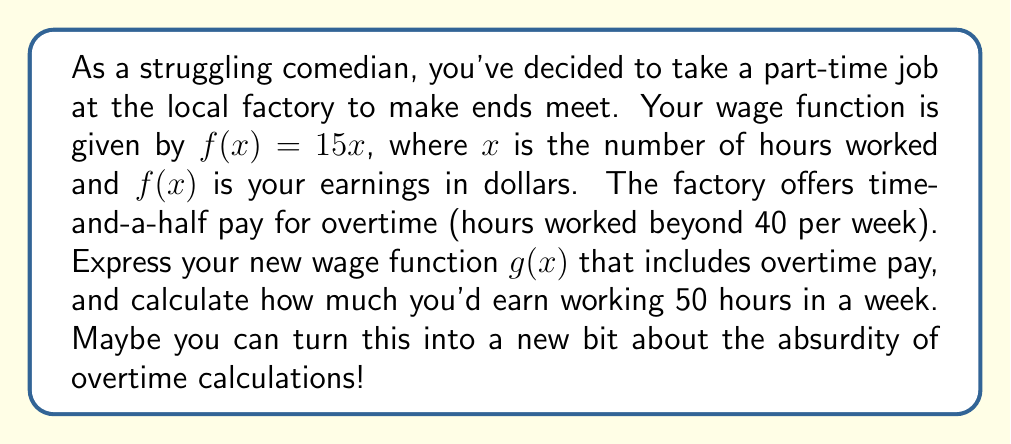Teach me how to tackle this problem. Let's break this down step-by-step:

1) First, we need to understand the original wage function:
   $f(x) = 15x$, where $15 is the hourly rate

2) For overtime, we need to split the function into two parts:
   - Regular pay for the first 40 hours
   - Overtime pay (1.5 times regular rate) for hours beyond 40

3) Let's express this mathematically:
   $g(x) = \begin{cases}
   15x & \text{if } x \leq 40 \\
   15(40) + 15(1.5)(x-40) & \text{if } x > 40
   \end{cases}$

4) Simplify the overtime case:
   $g(x) = \begin{cases}
   15x & \text{if } x \leq 40 \\
   600 + 22.5(x-40) & \text{if } x > 40
   \end{cases}$

5) To calculate earnings for 50 hours, we use the second case:
   $g(50) = 600 + 22.5(50-40)$
          $= 600 + 22.5(10)$
          $= 600 + 225$
          $= 825$

Therefore, working 50 hours would earn you $825.
Answer: $g(x) = \begin{cases}
15x & \text{if } x \leq 40 \\
600 + 22.5(x-40) & \text{if } x > 40
\end{cases}$; $825 